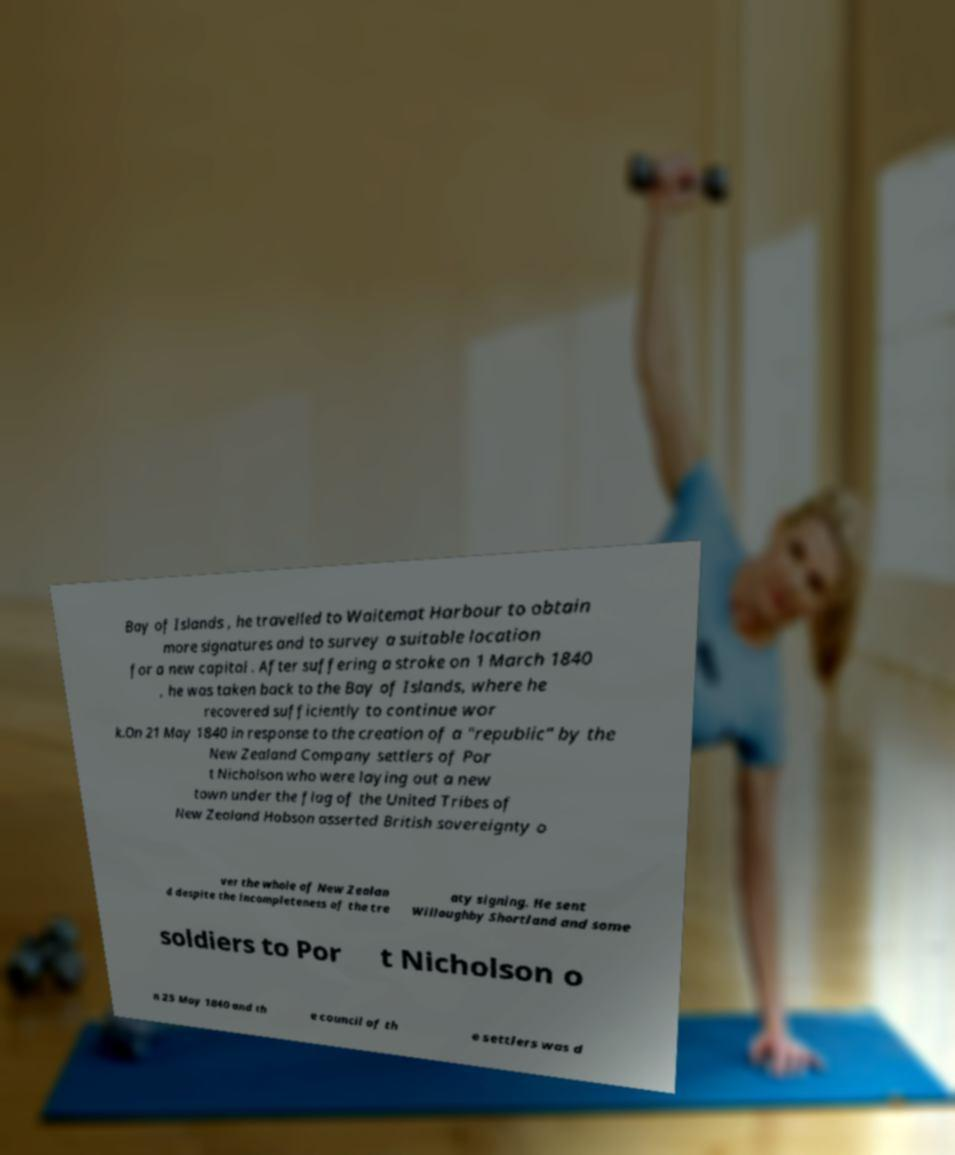Could you extract and type out the text from this image? Bay of Islands , he travelled to Waitemat Harbour to obtain more signatures and to survey a suitable location for a new capital . After suffering a stroke on 1 March 1840 , he was taken back to the Bay of Islands, where he recovered sufficiently to continue wor k.On 21 May 1840 in response to the creation of a "republic" by the New Zealand Company settlers of Por t Nicholson who were laying out a new town under the flag of the United Tribes of New Zealand Hobson asserted British sovereignty o ver the whole of New Zealan d despite the incompleteness of the tre aty signing. He sent Willoughby Shortland and some soldiers to Por t Nicholson o n 25 May 1840 and th e council of th e settlers was d 